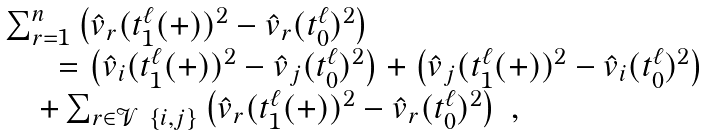Convert formula to latex. <formula><loc_0><loc_0><loc_500><loc_500>\begin{array} { l l l l } & \sum _ { r = 1 } ^ { n } \left ( \hat { v } _ { r } ( t ^ { \ell } _ { 1 } ( + ) ) ^ { 2 } - \hat { v } _ { r } ( t ^ { \ell } _ { 0 } ) ^ { 2 } \right ) \\ & \quad \ \ = \left ( \hat { v } _ { i } ( t ^ { \ell } _ { 1 } ( + ) ) ^ { 2 } - \hat { v } _ { j } ( t ^ { \ell } _ { 0 } ) ^ { 2 } \right ) + \left ( \hat { v } _ { j } ( t ^ { \ell } _ { 1 } ( + ) ) ^ { 2 } - \hat { v } _ { i } ( t ^ { \ell } _ { 0 } ) ^ { 2 } \right ) \\ & \quad + \sum _ { r \in \mathcal { V } \ \{ i , j \} } \left ( \hat { v } _ { r } ( t ^ { \ell } _ { 1 } ( + ) ) ^ { 2 } - \hat { v } _ { r } ( t ^ { \ell } _ { 0 } ) ^ { 2 } \right ) \ , \end{array}</formula> 